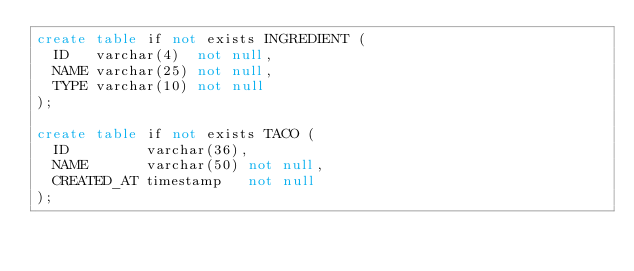<code> <loc_0><loc_0><loc_500><loc_500><_SQL_>create table if not exists INGREDIENT (
  ID   varchar(4)  not null,
  NAME varchar(25) not null,
  TYPE varchar(10) not null
);

create table if not exists TACO (
  ID         varchar(36),
  NAME       varchar(50) not null,
  CREATED_AT timestamp   not null
);
</code> 